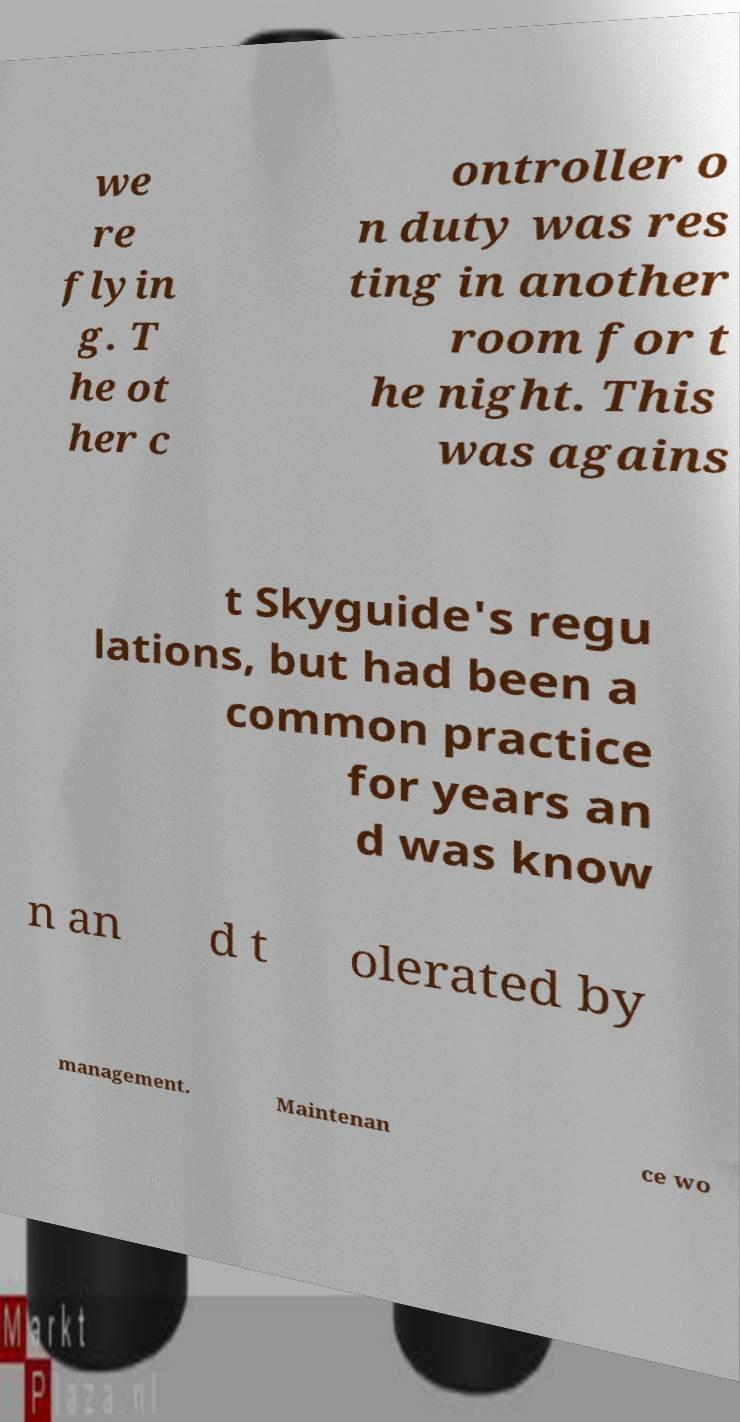What messages or text are displayed in this image? I need them in a readable, typed format. we re flyin g. T he ot her c ontroller o n duty was res ting in another room for t he night. This was agains t Skyguide's regu lations, but had been a common practice for years an d was know n an d t olerated by management. Maintenan ce wo 